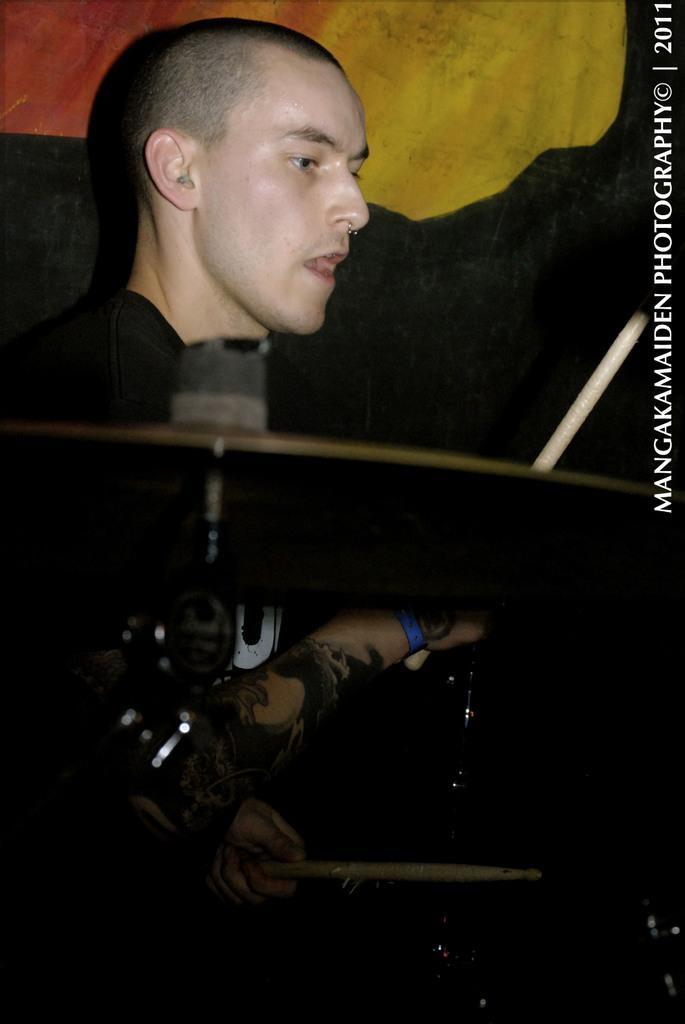In one or two sentences, can you explain what this image depicts? This is the man sitting and holding the sticks. I think this is a hi-hat instrument. This is the watermark on the image. 